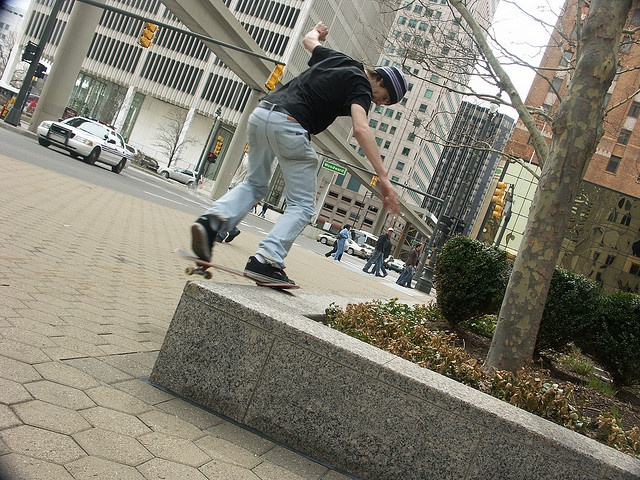Describe the objects in this image and their specific colors. I can see people in black, gray, and darkgray tones, car in black, white, darkgray, and gray tones, skateboard in black, darkgray, and gray tones, people in black, gray, lightgray, and purple tones, and people in black, darkgray, lightgray, and gray tones in this image. 